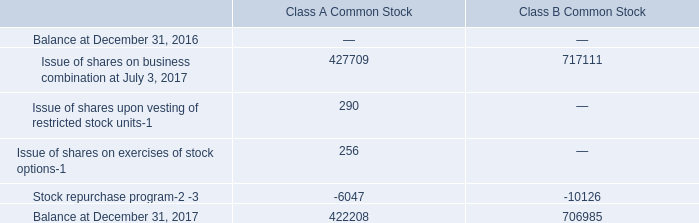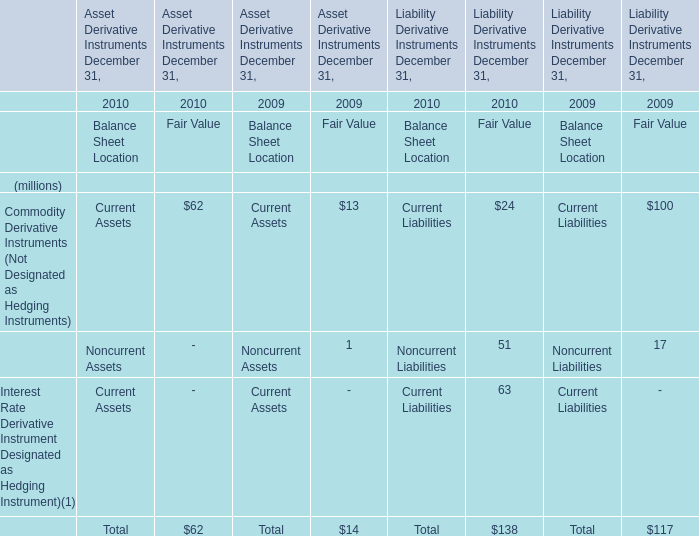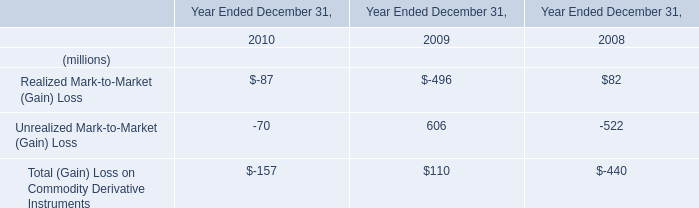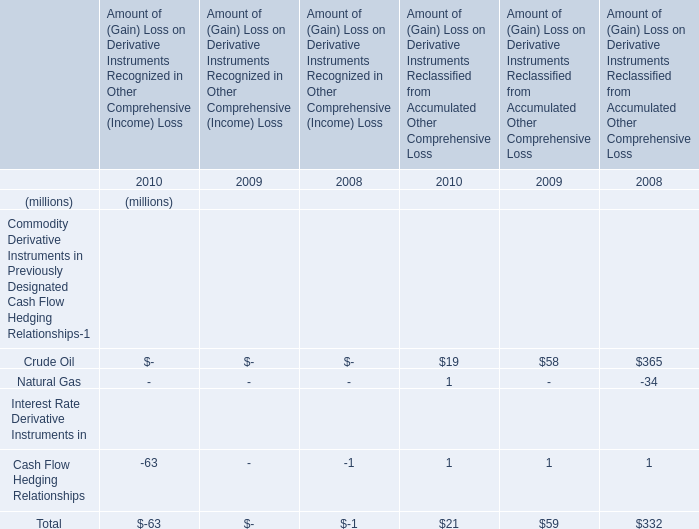Which year is Total (Gain) Loss on Commodity Derivative Instruments the most? 
Answer: 2009. 